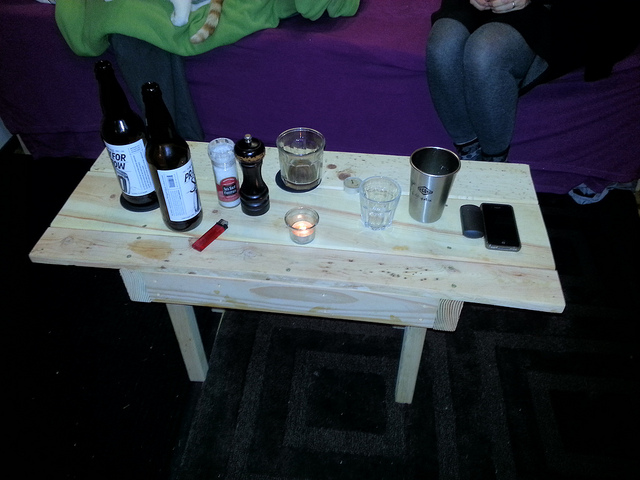Can you describe the overall atmosphere or setting this table is a part of? The table is part of a relaxed and casual setting, likely a small gathering or a personal space. The eclectic mix of items, ranging from beverage bottles to a smartphone, paired with the simplicity of a wooden table, suggests a laid-back atmosphere, possibly in a home or a friendly meet-up location where individuals feel comfortable. 